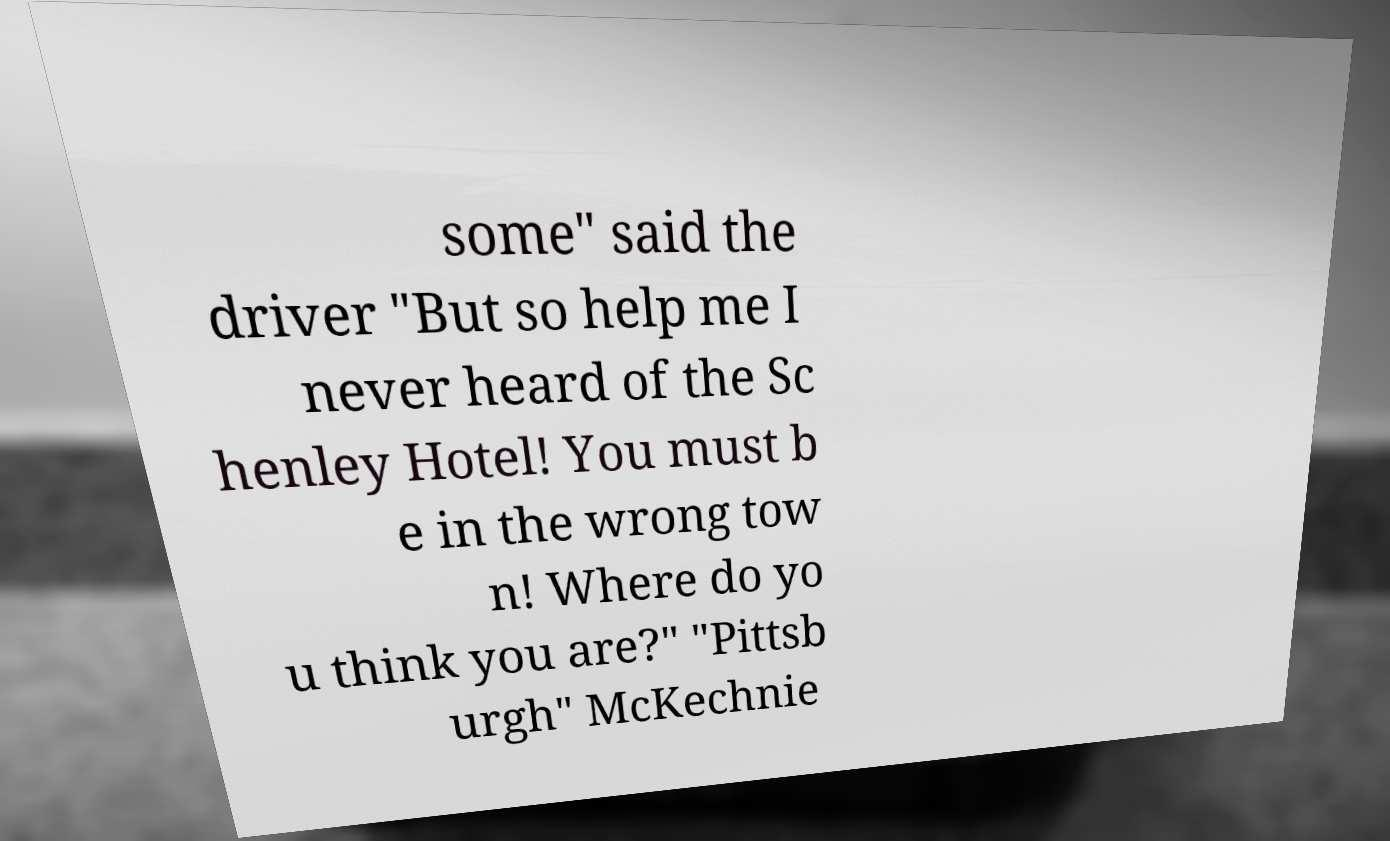Please identify and transcribe the text found in this image. some" said the driver "But so help me I never heard of the Sc henley Hotel! You must b e in the wrong tow n! Where do yo u think you are?" "Pittsb urgh" McKechnie 